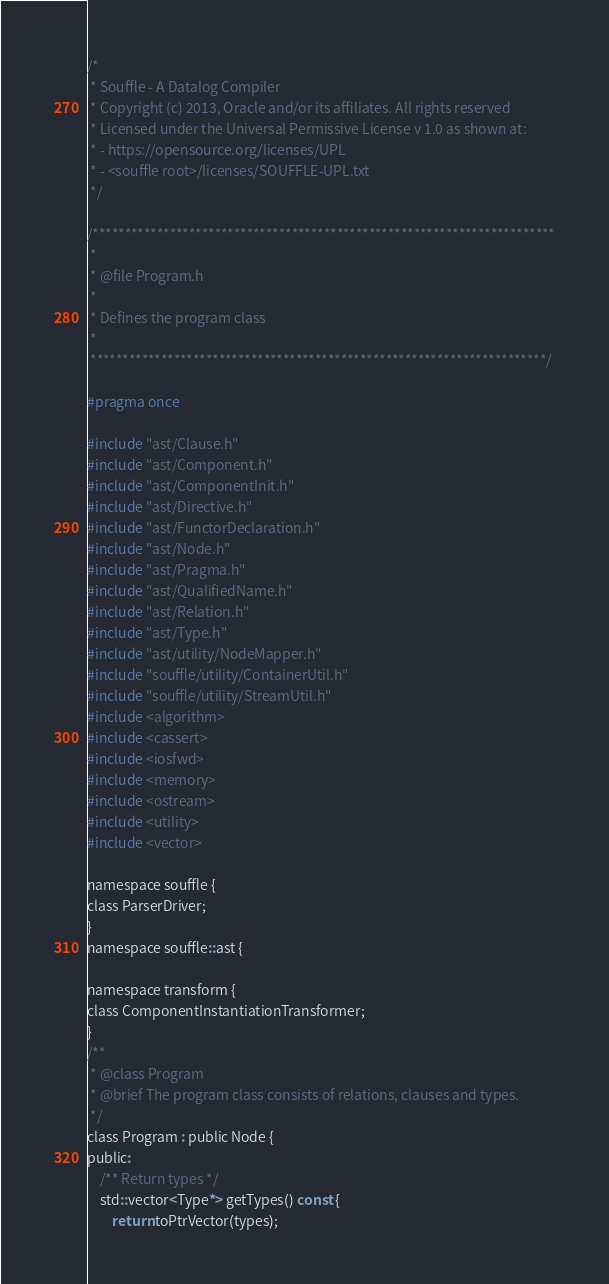<code> <loc_0><loc_0><loc_500><loc_500><_C_>/*
 * Souffle - A Datalog Compiler
 * Copyright (c) 2013, Oracle and/or its affiliates. All rights reserved
 * Licensed under the Universal Permissive License v 1.0 as shown at:
 * - https://opensource.org/licenses/UPL
 * - <souffle root>/licenses/SOUFFLE-UPL.txt
 */

/************************************************************************
 *
 * @file Program.h
 *
 * Defines the program class
 *
 ***********************************************************************/

#pragma once

#include "ast/Clause.h"
#include "ast/Component.h"
#include "ast/ComponentInit.h"
#include "ast/Directive.h"
#include "ast/FunctorDeclaration.h"
#include "ast/Node.h"
#include "ast/Pragma.h"
#include "ast/QualifiedName.h"
#include "ast/Relation.h"
#include "ast/Type.h"
#include "ast/utility/NodeMapper.h"
#include "souffle/utility/ContainerUtil.h"
#include "souffle/utility/StreamUtil.h"
#include <algorithm>
#include <cassert>
#include <iosfwd>
#include <memory>
#include <ostream>
#include <utility>
#include <vector>

namespace souffle {
class ParserDriver;
}
namespace souffle::ast {

namespace transform {
class ComponentInstantiationTransformer;
}
/**
 * @class Program
 * @brief The program class consists of relations, clauses and types.
 */
class Program : public Node {
public:
    /** Return types */
    std::vector<Type*> getTypes() const {
        return toPtrVector(types);</code> 